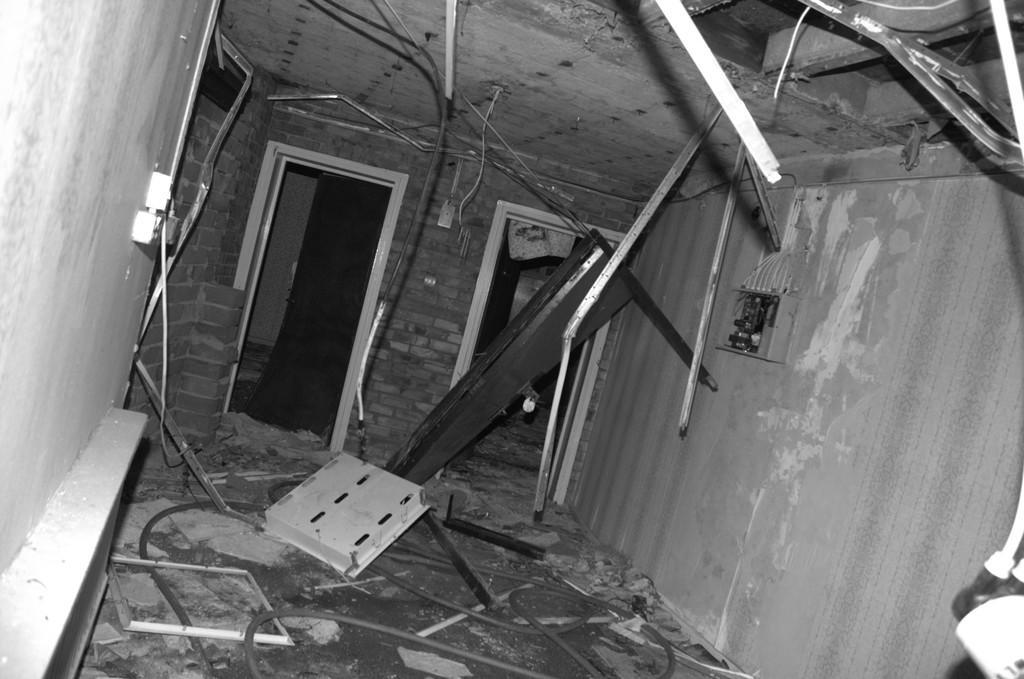In one or two sentences, can you explain what this image depicts? This image is clicked inside the building. There are many metal stands and doors. To the left, there is a wall. At the bottom, there is a floor. At the top, there is a roof. 